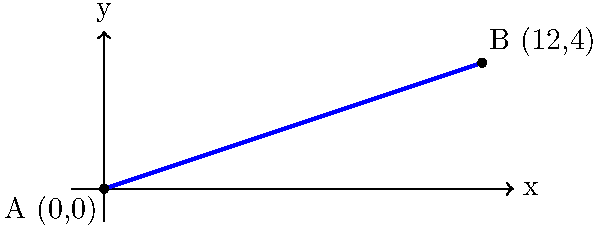On a construction site, you need to determine the slope of a ramp. The base of the ramp is at point A (0,0), and the top of the ramp is at point B (12,4). Calculate the slope of this ramp. To find the slope of the ramp, we'll use the slope formula:

$$ \text{Slope} = \frac{\text{Rise}}{\text{Run}} = \frac{y_2 - y_1}{x_2 - x_1} $$

Where $(x_1, y_1)$ is the first point and $(x_2, y_2)$ is the second point.

Step 1: Identify the coordinates
Point A: $(x_1, y_1) = (0, 0)$
Point B: $(x_2, y_2) = (12, 4)$

Step 2: Calculate the rise (vertical change)
Rise $= y_2 - y_1 = 4 - 0 = 4$

Step 3: Calculate the run (horizontal change)
Run $= x_2 - x_1 = 12 - 0 = 12$

Step 4: Apply the slope formula
$$ \text{Slope} = \frac{\text{Rise}}{\text{Run}} = \frac{4}{12} $$

Step 5: Simplify the fraction
$$ \text{Slope} = \frac{4}{12} = \frac{1}{3} $$

Therefore, the slope of the ramp is $\frac{1}{3}$ or 0.333 (rounded to three decimal places).
Answer: $\frac{1}{3}$ 